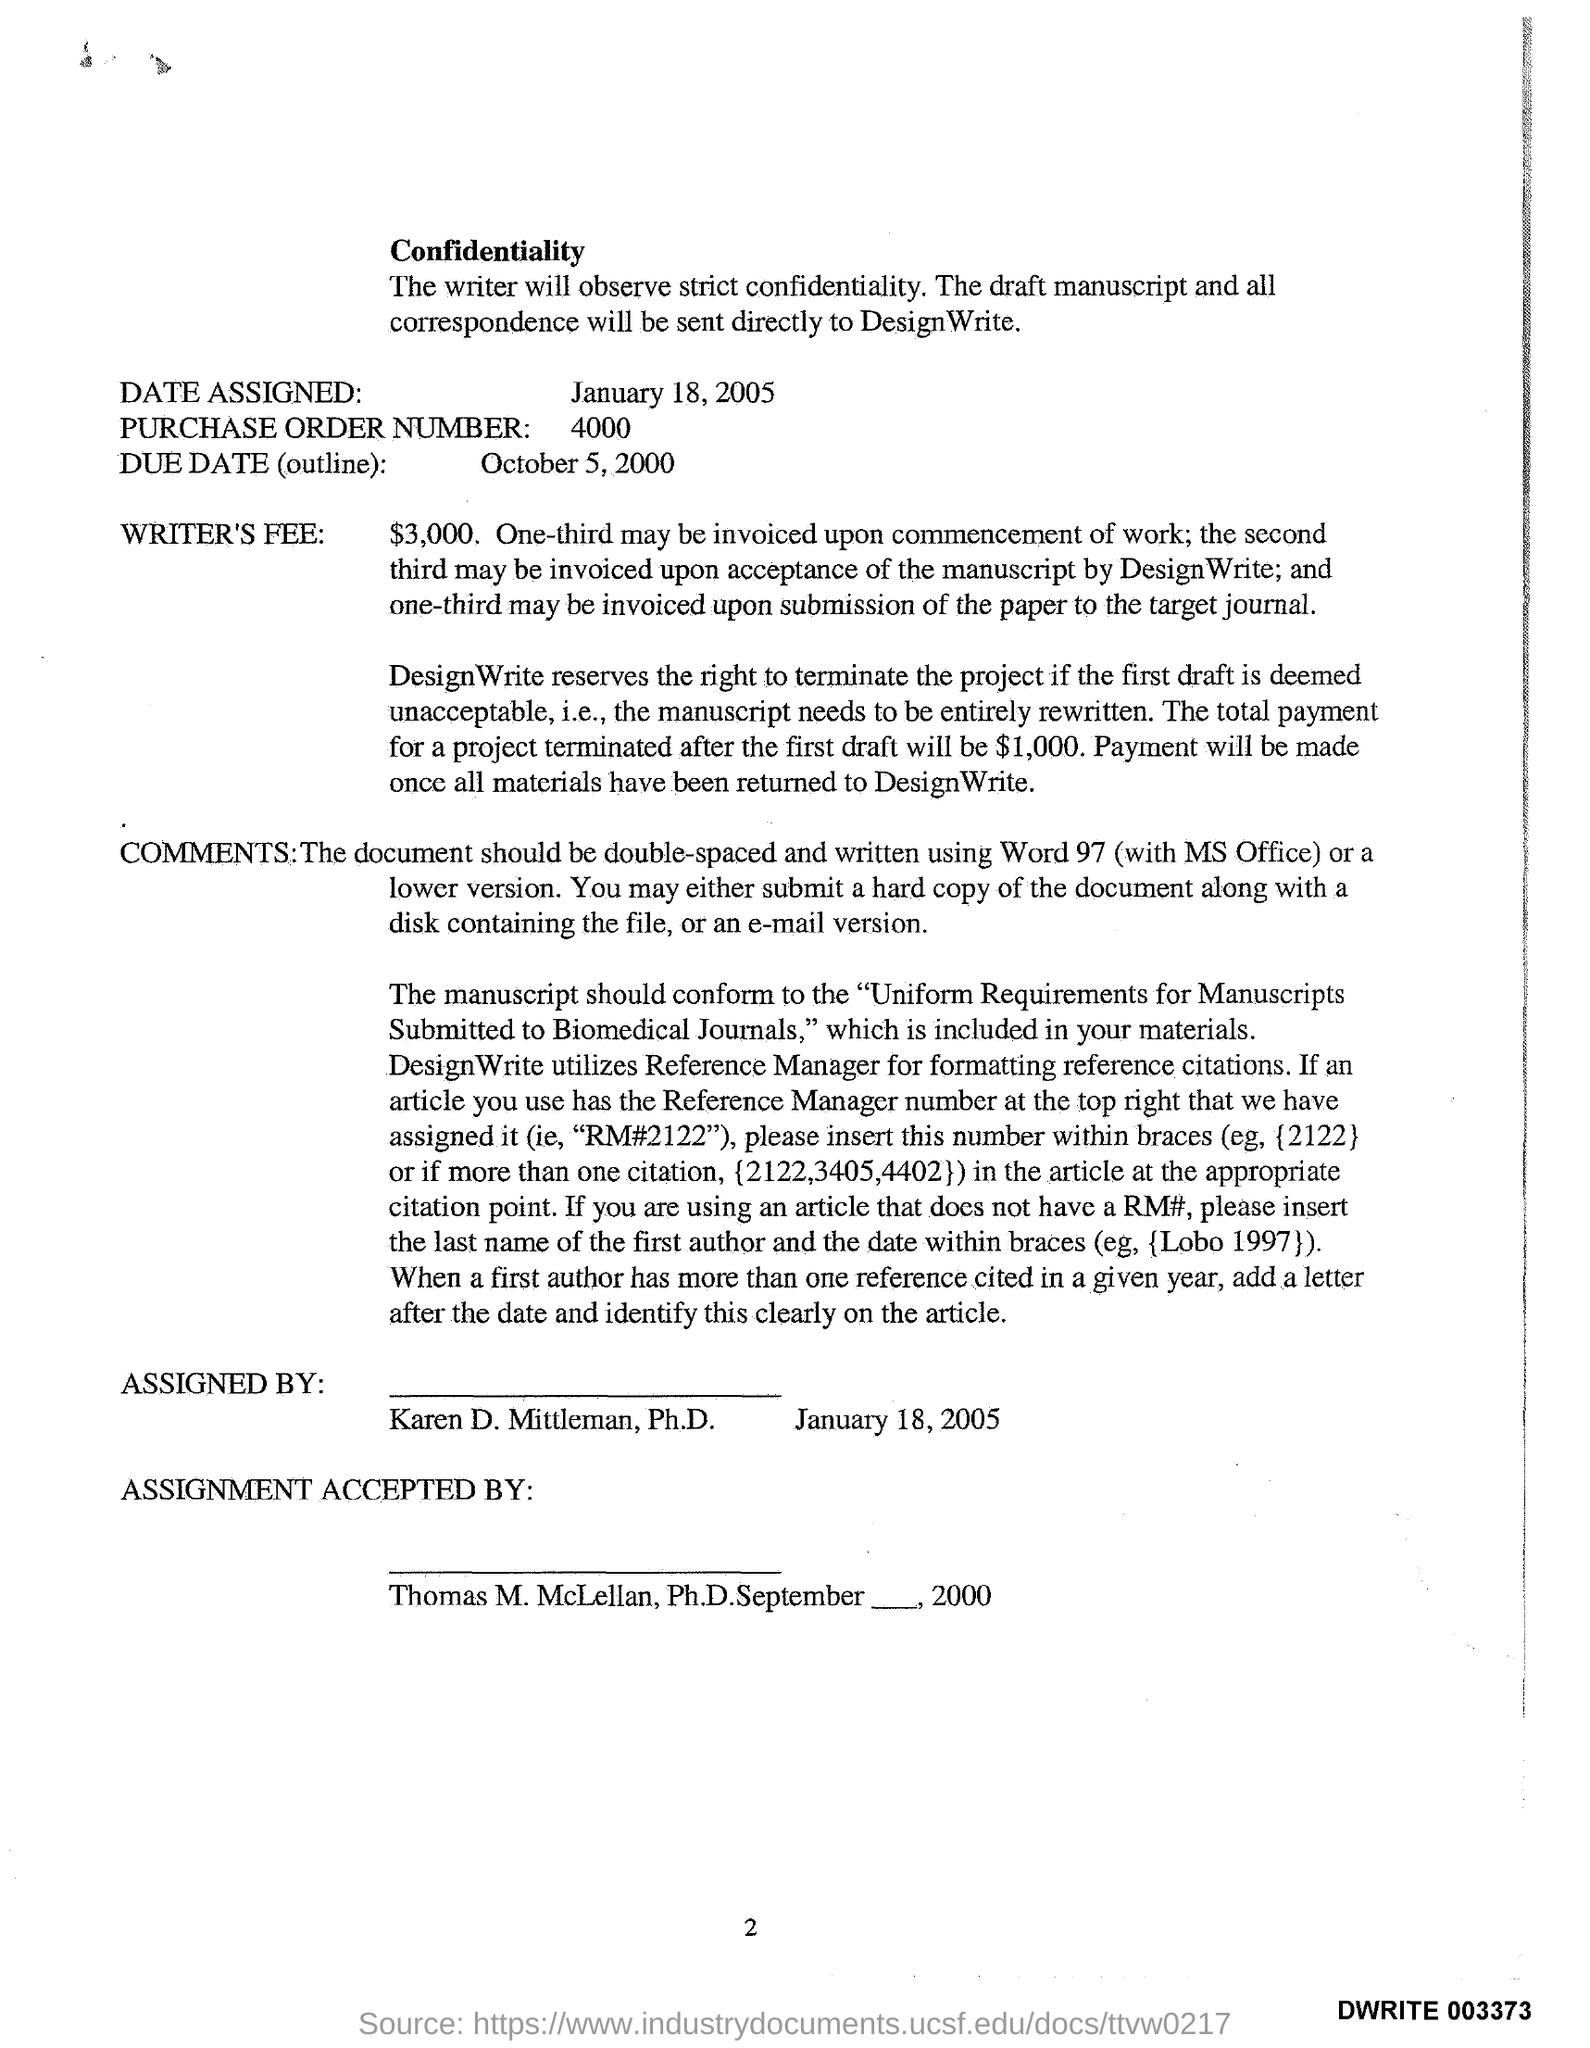Identify some key points in this picture. The date assigned as per the document is January 18, 2005. The Writer's Fee is $3,000. The purchase order number provided in the document is 4000. The due date mentioned in the document is October 5, 2000. The page number referenced in this document is 2. 